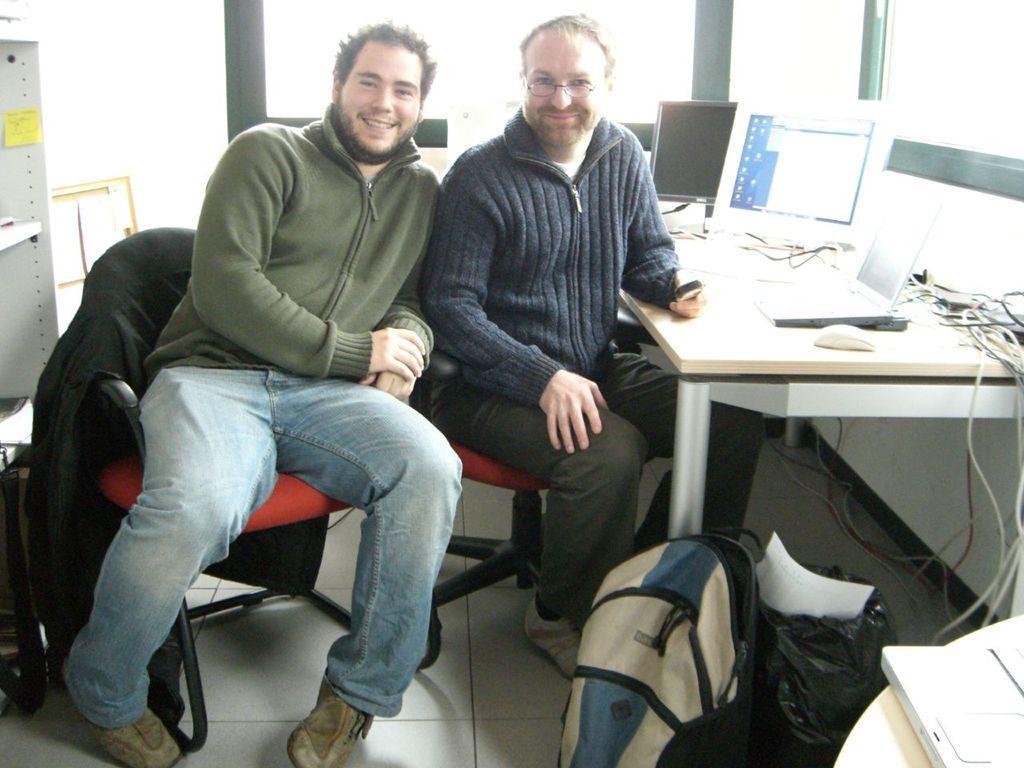How would you summarize this image in a sentence or two? Two men sitting in chair are posing at camera and smiling. 